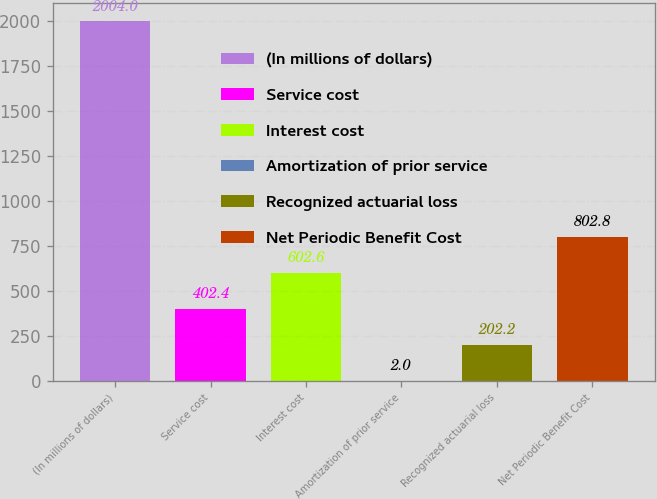<chart> <loc_0><loc_0><loc_500><loc_500><bar_chart><fcel>(In millions of dollars)<fcel>Service cost<fcel>Interest cost<fcel>Amortization of prior service<fcel>Recognized actuarial loss<fcel>Net Periodic Benefit Cost<nl><fcel>2004<fcel>402.4<fcel>602.6<fcel>2<fcel>202.2<fcel>802.8<nl></chart> 